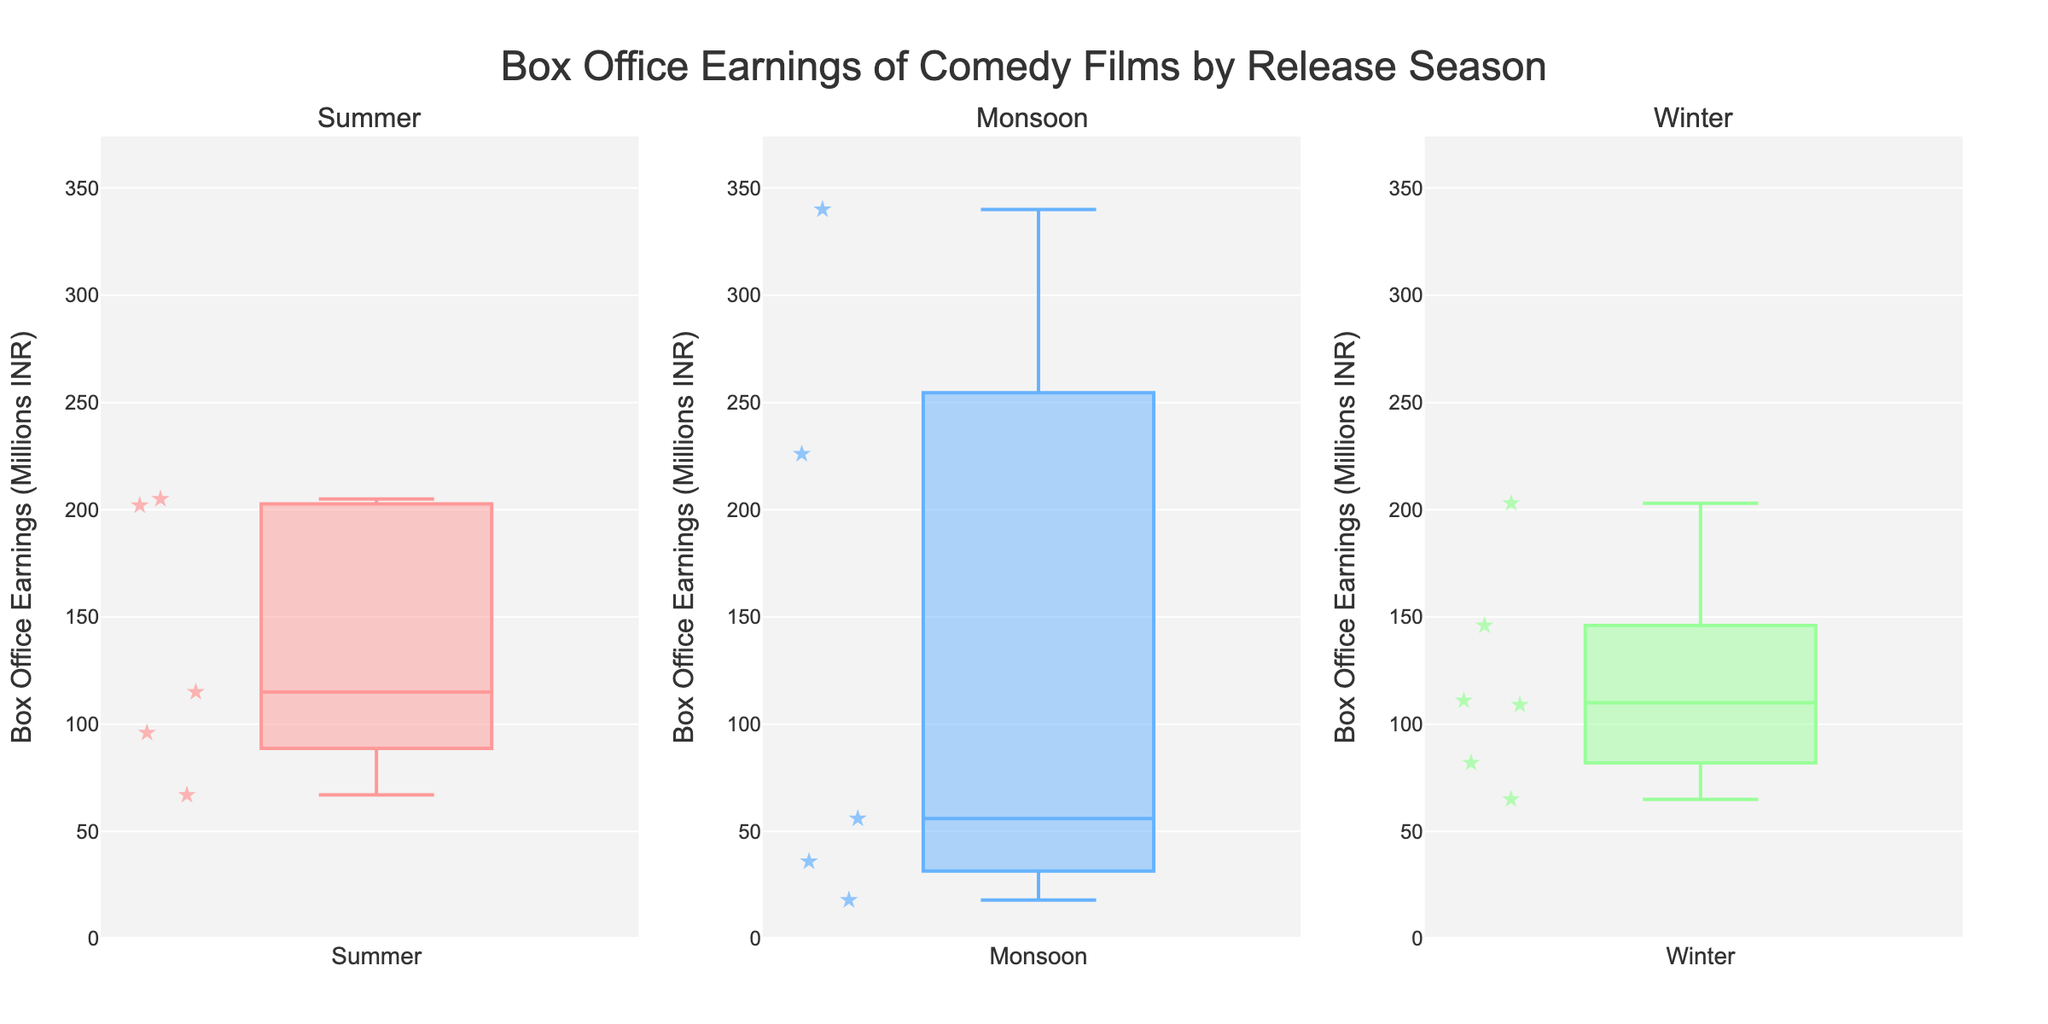How many seasons are displayed in the figure? There are three subplot titles in the figure, each representing a different season of film release.
Answer: 3 What is the highest Box Office Earnings for any movie in the Winter season? Looking at the box plot for the Winter season, the highest data point for Box Office Earnings (also called the maximum outlier) is around 203 million INR, corresponding to "Happy New Year".
Answer: 203 million INR Which season shows the widest range of Box Office Earnings? The range of earnings displayed in a box plot is from the lowest value to the highest value (including outliers). By comparing the vertical spread of the three box plots, the Monsoon season shows the widest range, as it extends from approximately 18 million INR to 340 million INR.
Answer: Monsoon What's the median Box Office Earnings for movies released in the Monsoon season? In a box plot, the median is indicated by the line inside the box. For the Monsoon season, the line is approximately at 46 million INR.
Answer: 46 million INR Compare the interquartile ranges (IQR) of earnings for the Summer and Winter seasons. Which is broader? The IQR is the distance between the first quartile (bottom of the box) and the third quartile (top of the box). For the Summer season, the IQR appears to be from around 90 to 170 million INR (80 million INR range). For the Winter season, the IQR is from around 90 to 140 million INR (50 million INR range). Therefore, the Summer season has a broader IQR.
Answer: Summer What is the difference between the highest earnings in the Monsoon season and the highest earnings in the Summer season? The highest earnings in the Monsoon season are approximately 340 million INR, and the highest in the Summer season is about 205 million INR. Subtracting the Summer season's highest earnings from the Monsoon season's highest gives 340 - 205 = 135 million INR.
Answer: 135 million INR Which season has the least variability in Box Office Earnings? Variability in earnings can be inferred from the spread of the box plot and the presence of outliers. Comparing all three seasons, the Winter season has the least variability because its box plot is the most compact and has fewer extreme outliers compared to the others.
Answer: Winter What is the median earnings difference between the highest and lowest grossing films in the Summer season? First, find the highest and lowest values in the Summer box plot, which are approximately 205 million INR and 67 million INR. The difference between them is 205 - 67 = 138 million INR.
Answer: 138 million INR Which is the least earning movie and what season was it released? The least earning movie is the one with the smallest Box Office Earnings. From the plots, the smallest value is seen in the Monsoon season's plot and is approximately 18 million INR for the movie "Masti".
Answer: Masti, Monsoon 